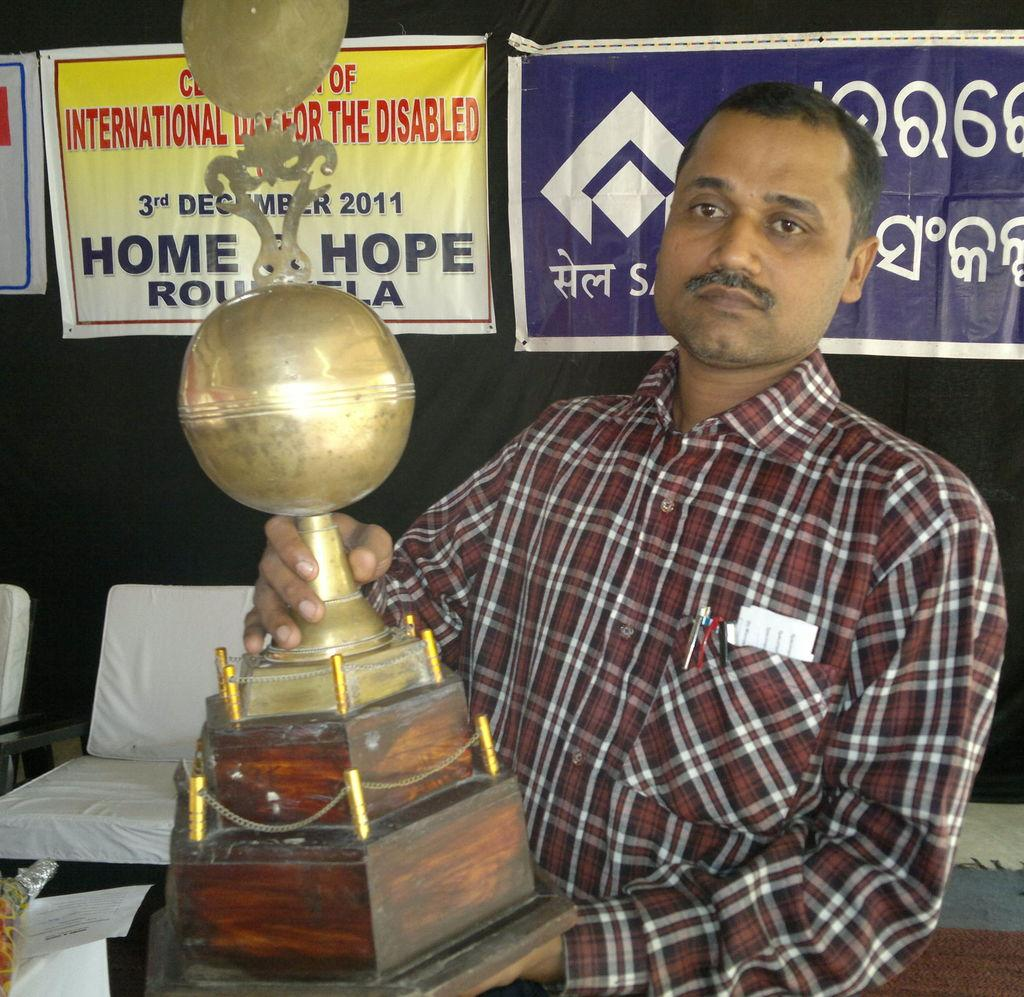Who is the main subject in the image? There is a man in the image. What is the man holding in the image? The man is holding a trophy. What can be seen in the background of the image? There are chairs and a wall with banners in the image. What is written on the banners? There is text on the banners. What type of soap is being used to clean the front of the banners in the image? There is no soap or cleaning activity depicted in the image; the banners have text on them. 